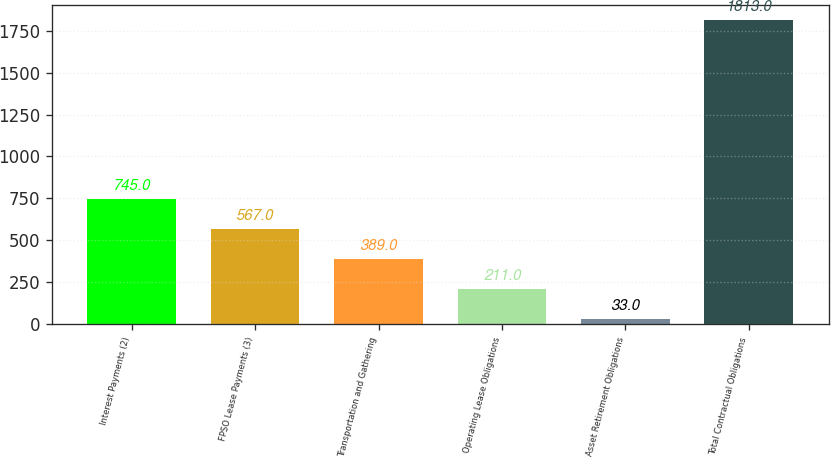Convert chart to OTSL. <chart><loc_0><loc_0><loc_500><loc_500><bar_chart><fcel>Interest Payments (2)<fcel>FPSO Lease Payments (3)<fcel>Transportation and Gathering<fcel>Operating Lease Obligations<fcel>Asset Retirement Obligations<fcel>Total Contractual Obligations<nl><fcel>745<fcel>567<fcel>389<fcel>211<fcel>33<fcel>1813<nl></chart> 